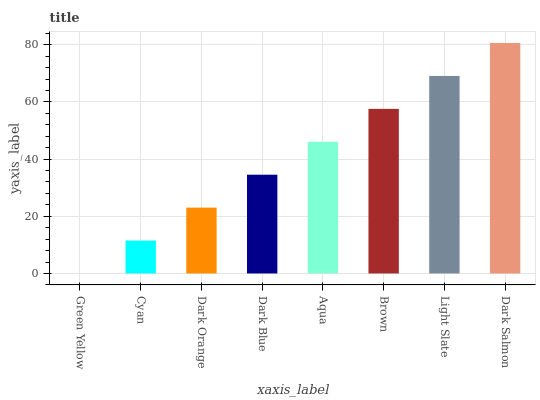Is Green Yellow the minimum?
Answer yes or no. Yes. Is Dark Salmon the maximum?
Answer yes or no. Yes. Is Cyan the minimum?
Answer yes or no. No. Is Cyan the maximum?
Answer yes or no. No. Is Cyan greater than Green Yellow?
Answer yes or no. Yes. Is Green Yellow less than Cyan?
Answer yes or no. Yes. Is Green Yellow greater than Cyan?
Answer yes or no. No. Is Cyan less than Green Yellow?
Answer yes or no. No. Is Aqua the high median?
Answer yes or no. Yes. Is Dark Blue the low median?
Answer yes or no. Yes. Is Green Yellow the high median?
Answer yes or no. No. Is Brown the low median?
Answer yes or no. No. 